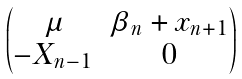<formula> <loc_0><loc_0><loc_500><loc_500>\begin{pmatrix} \mu & \beta _ { n } + x _ { n + 1 } \\ - X _ { n - 1 } & 0 \end{pmatrix}</formula> 